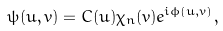Convert formula to latex. <formula><loc_0><loc_0><loc_500><loc_500>\psi ( u , v ) = C ( u ) \chi _ { n } ( v ) e ^ { i \phi ( u , v ) } ,</formula> 